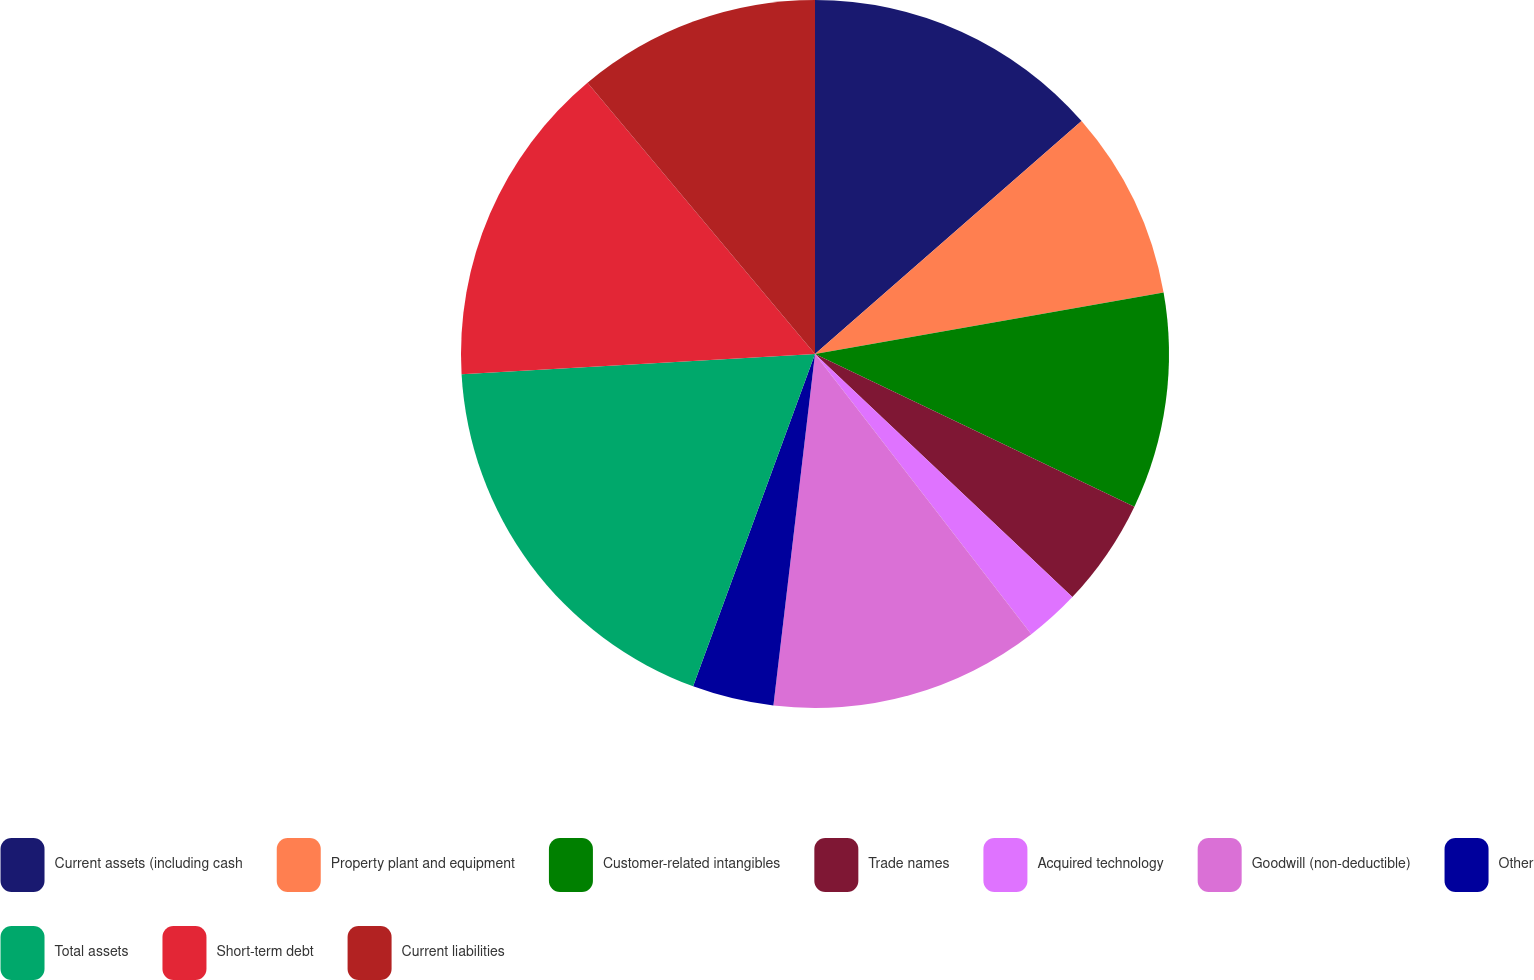Convert chart to OTSL. <chart><loc_0><loc_0><loc_500><loc_500><pie_chart><fcel>Current assets (including cash<fcel>Property plant and equipment<fcel>Customer-related intangibles<fcel>Trade names<fcel>Acquired technology<fcel>Goodwill (non-deductible)<fcel>Other<fcel>Total assets<fcel>Short-term debt<fcel>Current liabilities<nl><fcel>13.57%<fcel>8.65%<fcel>9.88%<fcel>4.95%<fcel>2.49%<fcel>12.34%<fcel>3.72%<fcel>18.5%<fcel>14.8%<fcel>11.11%<nl></chart> 